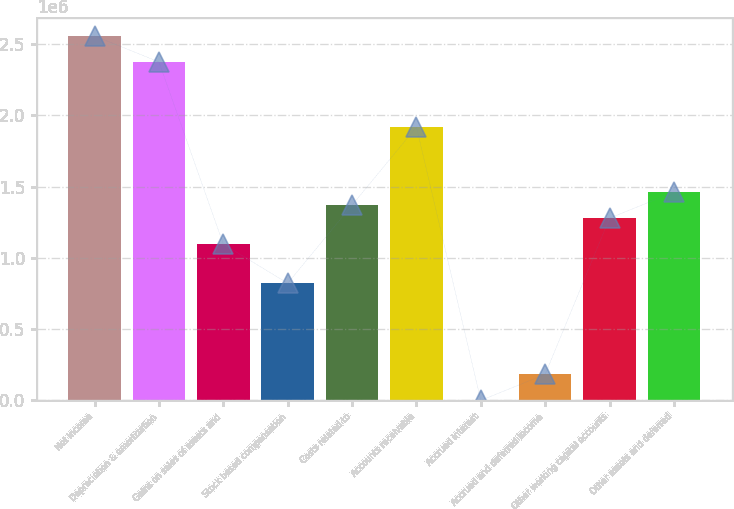<chart> <loc_0><loc_0><loc_500><loc_500><bar_chart><fcel>Net income<fcel>Depreciation & amortization<fcel>Gains on sales of assets and<fcel>Stock based compensation<fcel>Costs related to<fcel>Accounts receivable<fcel>Accrued interest<fcel>Accrued and deferred income<fcel>Other working capital accounts<fcel>Other assets and deferred<nl><fcel>2.55753e+06<fcel>2.37486e+06<fcel>1.09617e+06<fcel>822165<fcel>1.37017e+06<fcel>1.91818e+06<fcel>152<fcel>182822<fcel>1.27884e+06<fcel>1.46151e+06<nl></chart> 